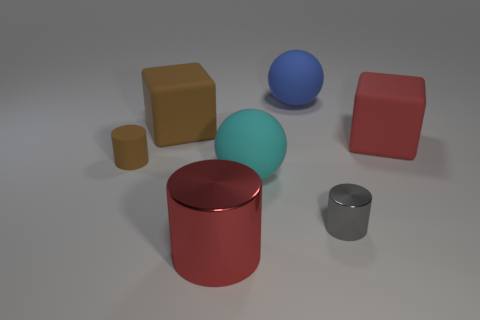How many large matte things are there?
Provide a succinct answer. 4. What is the color of the big matte object that is behind the cyan object and to the left of the blue rubber sphere?
Your answer should be very brief. Brown. The other object that is the same shape as the blue matte object is what size?
Provide a short and direct response. Large. What number of rubber cubes are the same size as the cyan ball?
Offer a terse response. 2. What is the material of the big red cube?
Your answer should be very brief. Rubber. Are there any small brown matte cylinders to the right of the big cyan object?
Give a very brief answer. No. There is a red cube that is the same material as the cyan sphere; what is its size?
Your answer should be very brief. Large. What number of big matte cubes have the same color as the small rubber cylinder?
Keep it short and to the point. 1. Is the number of tiny matte cylinders that are right of the large cyan thing less than the number of tiny brown matte objects to the right of the gray metallic cylinder?
Give a very brief answer. No. There is a block that is left of the cyan rubber object; how big is it?
Ensure brevity in your answer.  Large. 